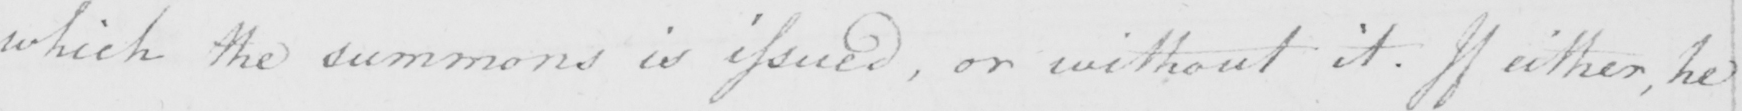What text is written in this handwritten line? which the summons is issued , or without it . If either , he 